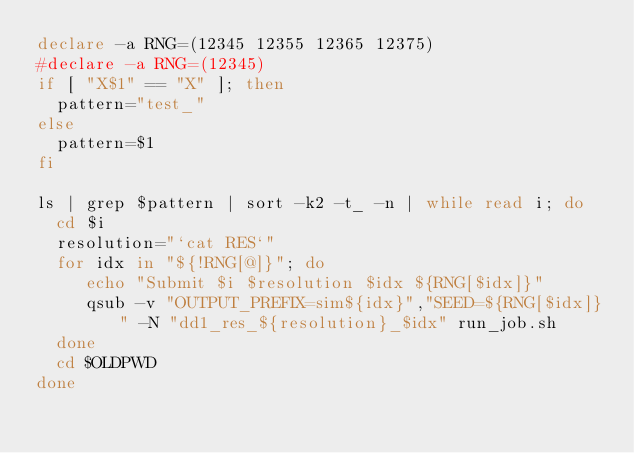<code> <loc_0><loc_0><loc_500><loc_500><_Bash_>declare -a RNG=(12345 12355 12365 12375)
#declare -a RNG=(12345)
if [ "X$1" == "X" ]; then
  pattern="test_"
else
  pattern=$1
fi

ls | grep $pattern | sort -k2 -t_ -n | while read i; do
  cd $i
  resolution="`cat RES`"
  for idx in "${!RNG[@]}"; do
     echo "Submit $i $resolution $idx ${RNG[$idx]}"
     qsub -v "OUTPUT_PREFIX=sim${idx}","SEED=${RNG[$idx]}" -N "dd1_res_${resolution}_$idx" run_job.sh
  done
  cd $OLDPWD 
done
</code> 